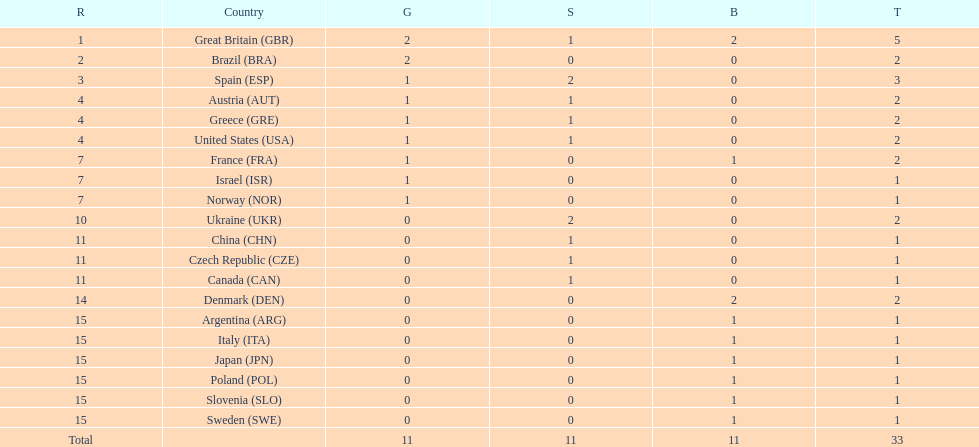Which nation was the only one to receive 3 medals? Spain (ESP). 